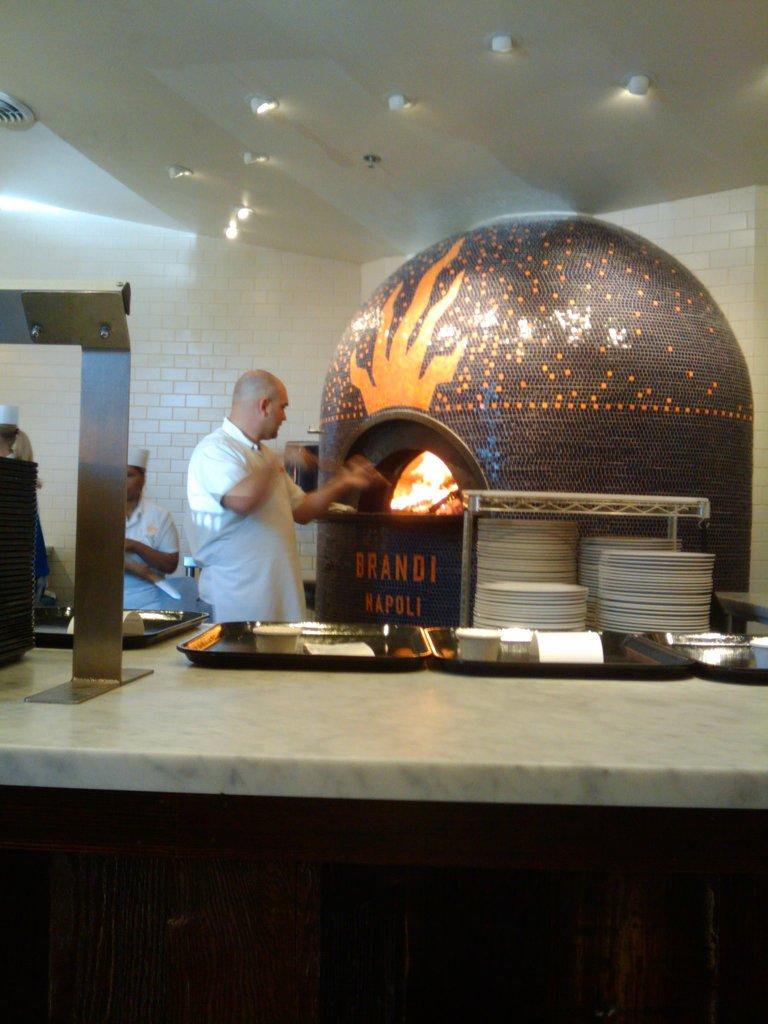What is written on the fire oven?
Give a very brief answer. Brandi napoli. What name is seen on the wood fired oven?
Give a very brief answer. Brandi napoli. 